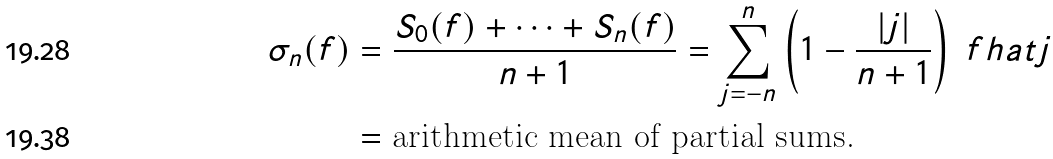Convert formula to latex. <formula><loc_0><loc_0><loc_500><loc_500>\sigma _ { n } ( f ) & = \frac { S _ { 0 } ( f ) + \cdots + S _ { n } ( f ) } { n + 1 } = \sum _ { j = - n } ^ { n } \left ( 1 - \frac { | j | } { n + 1 } \right ) \ f h a t j \\ & = \text {arithmetic mean of partial sums.}</formula> 